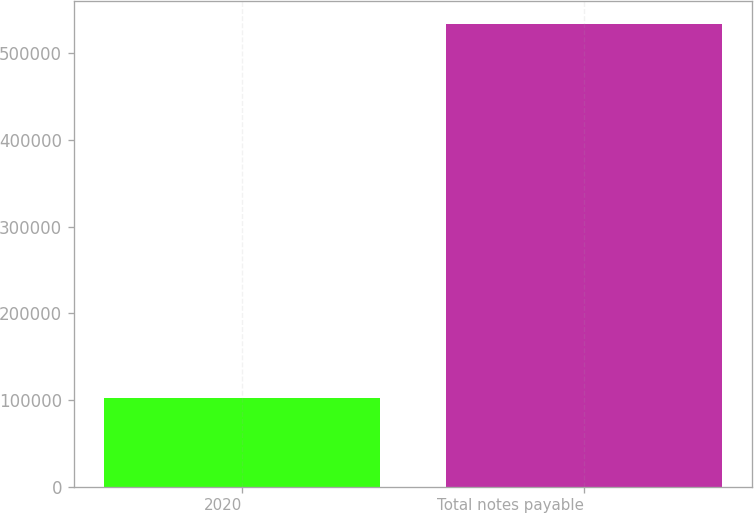Convert chart. <chart><loc_0><loc_0><loc_500><loc_500><bar_chart><fcel>2020<fcel>Total notes payable<nl><fcel>101841<fcel>533973<nl></chart> 